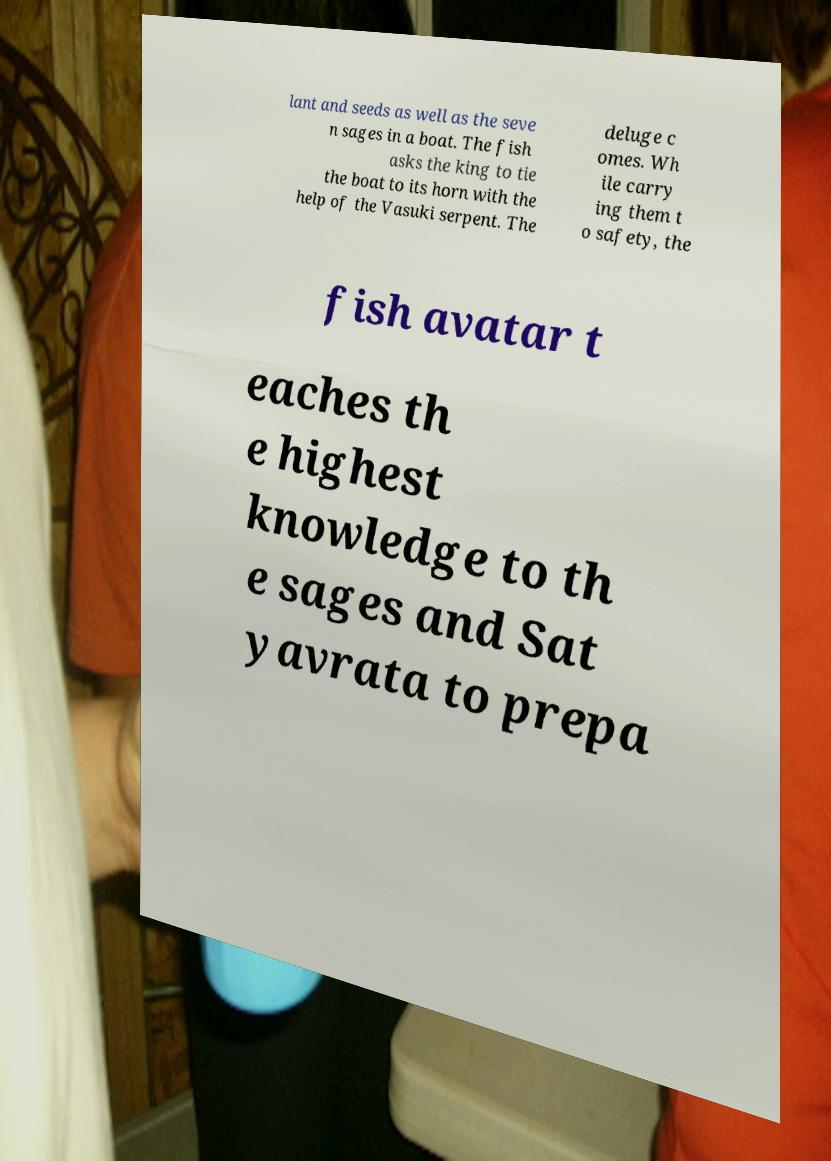What messages or text are displayed in this image? I need them in a readable, typed format. lant and seeds as well as the seve n sages in a boat. The fish asks the king to tie the boat to its horn with the help of the Vasuki serpent. The deluge c omes. Wh ile carry ing them t o safety, the fish avatar t eaches th e highest knowledge to th e sages and Sat yavrata to prepa 